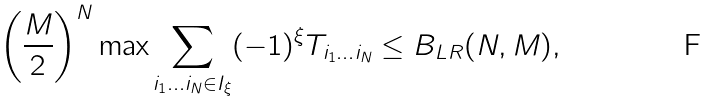Convert formula to latex. <formula><loc_0><loc_0><loc_500><loc_500>\left ( \frac { M } { 2 } \right ) ^ { N } \max \sum _ { i _ { 1 } \dots i _ { N } \in I _ { \xi } } ( - 1 ) ^ { \xi } T _ { i _ { 1 } \dots i _ { N } } \leq B _ { L R } ( N , M ) ,</formula> 